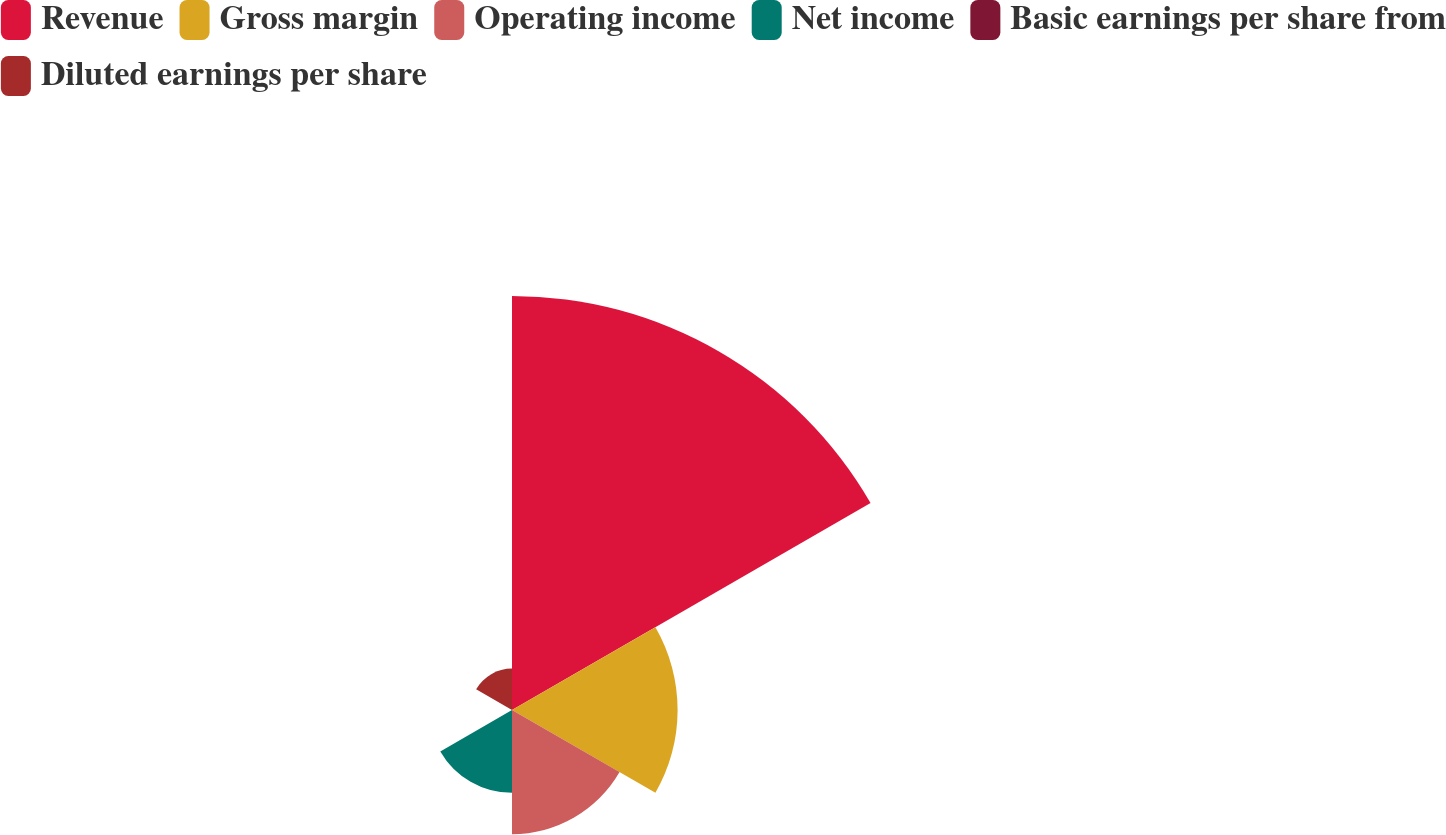Convert chart. <chart><loc_0><loc_0><loc_500><loc_500><pie_chart><fcel>Revenue<fcel>Gross margin<fcel>Operating income<fcel>Net income<fcel>Basic earnings per share from<fcel>Diluted earnings per share<nl><fcel>50.0%<fcel>20.0%<fcel>15.0%<fcel>10.0%<fcel>0.0%<fcel>5.0%<nl></chart> 